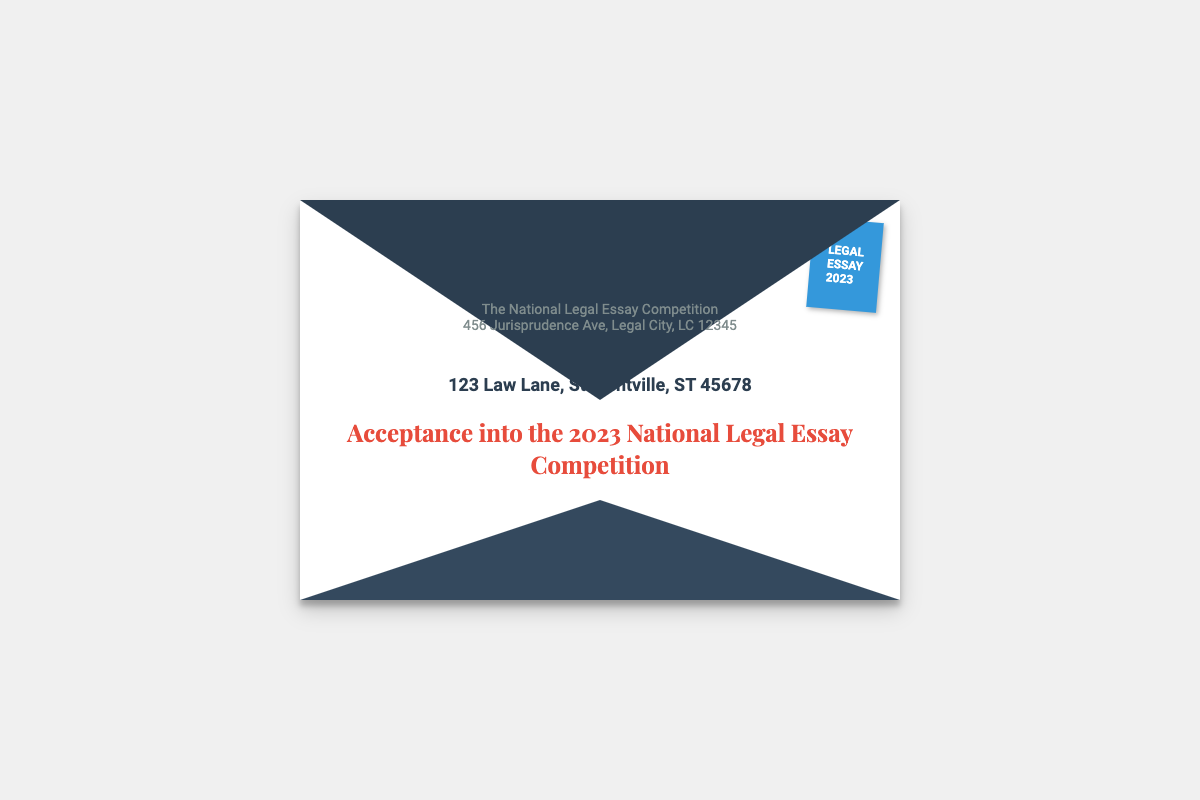What is the name of the competition? The name of the competition is explicitly stated in the letter as the "National Legal Essay Competition."
Answer: National Legal Essay Competition Who is the recipient of the acceptance letter? The document clearly lists the recipient's name at the beginning; therefore, it can be determined as "Jane Doe."
Answer: Jane Doe What year is the competition taking place? The document mentions the relevant year in the subject line, highlighting it as the year the competition occurs, which is "2023."
Answer: 2023 What is the address of the sender? The sender's address can be found within the sender's block, which includes "456 Jurisprudence Ave, Legal City, LC 12345."
Answer: 456 Jurisprudence Ave, Legal City, LC 12345 What is the color of the stamp on the envelope? The color of the stamp is seen visually and can be stated as "blue."
Answer: blue What is the title of the subject in the document? The title of the subject is given in a specific format within the content of the envelope, stated as "Acceptance into the 2023 National Legal Essay Competition."
Answer: Acceptance into the 2023 National Legal Essay Competition How is the recipient’s address formatted? The recipient's address appears with the name followed by a full address in two separate lines, indicating a specific format typically used in formal letters.
Answer: Two lines What is the primary purpose of this document? The document serves a primary function as a notification for acceptance into a competition, which can be directly inferred from the subject line and content.
Answer: Notification of acceptance What is the aesthetics feature of the envelope? The envelope demonstrates a visual design element which includes a distinctive color scheme and a shadow effect, enhancing its overall appearance and also indicating its formal nature.
Answer: Formal appearance 